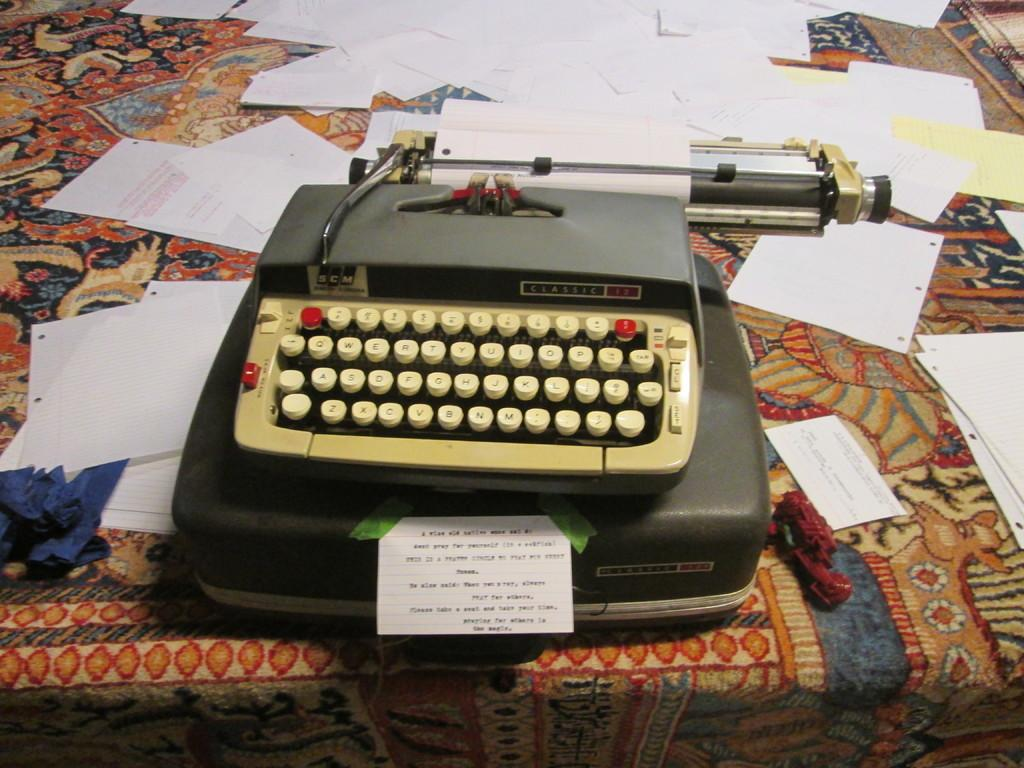<image>
Summarize the visual content of the image. A typewriter with a qwerty keyboard on a rug. 